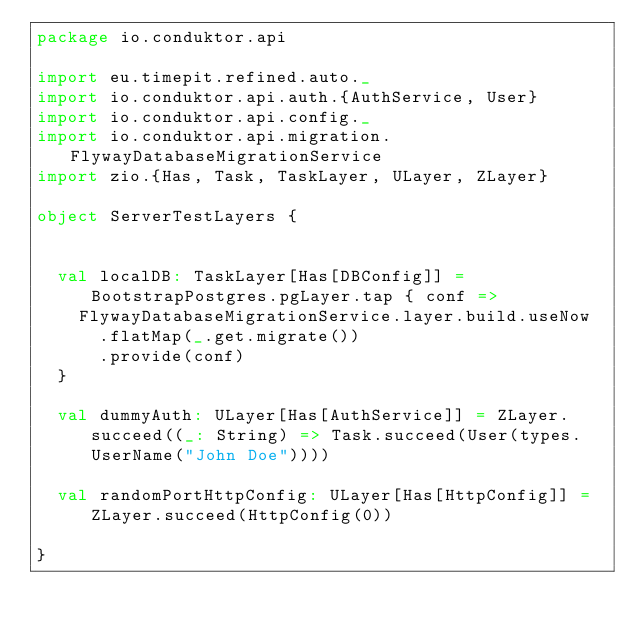<code> <loc_0><loc_0><loc_500><loc_500><_Scala_>package io.conduktor.api

import eu.timepit.refined.auto._
import io.conduktor.api.auth.{AuthService, User}
import io.conduktor.api.config._
import io.conduktor.api.migration.FlywayDatabaseMigrationService
import zio.{Has, Task, TaskLayer, ULayer, ZLayer}

object ServerTestLayers {


  val localDB: TaskLayer[Has[DBConfig]] = BootstrapPostgres.pgLayer.tap { conf =>
    FlywayDatabaseMigrationService.layer.build.useNow
      .flatMap(_.get.migrate())
      .provide(conf)
  }

  val dummyAuth: ULayer[Has[AuthService]] = ZLayer.succeed((_: String) => Task.succeed(User(types.UserName("John Doe"))))

  val randomPortHttpConfig: ULayer[Has[HttpConfig]] = ZLayer.succeed(HttpConfig(0))

}
</code> 